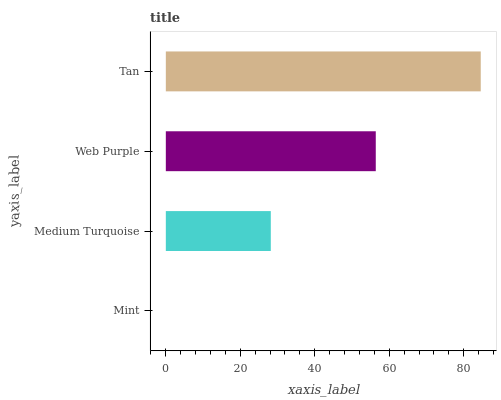Is Mint the minimum?
Answer yes or no. Yes. Is Tan the maximum?
Answer yes or no. Yes. Is Medium Turquoise the minimum?
Answer yes or no. No. Is Medium Turquoise the maximum?
Answer yes or no. No. Is Medium Turquoise greater than Mint?
Answer yes or no. Yes. Is Mint less than Medium Turquoise?
Answer yes or no. Yes. Is Mint greater than Medium Turquoise?
Answer yes or no. No. Is Medium Turquoise less than Mint?
Answer yes or no. No. Is Web Purple the high median?
Answer yes or no. Yes. Is Medium Turquoise the low median?
Answer yes or no. Yes. Is Medium Turquoise the high median?
Answer yes or no. No. Is Mint the low median?
Answer yes or no. No. 